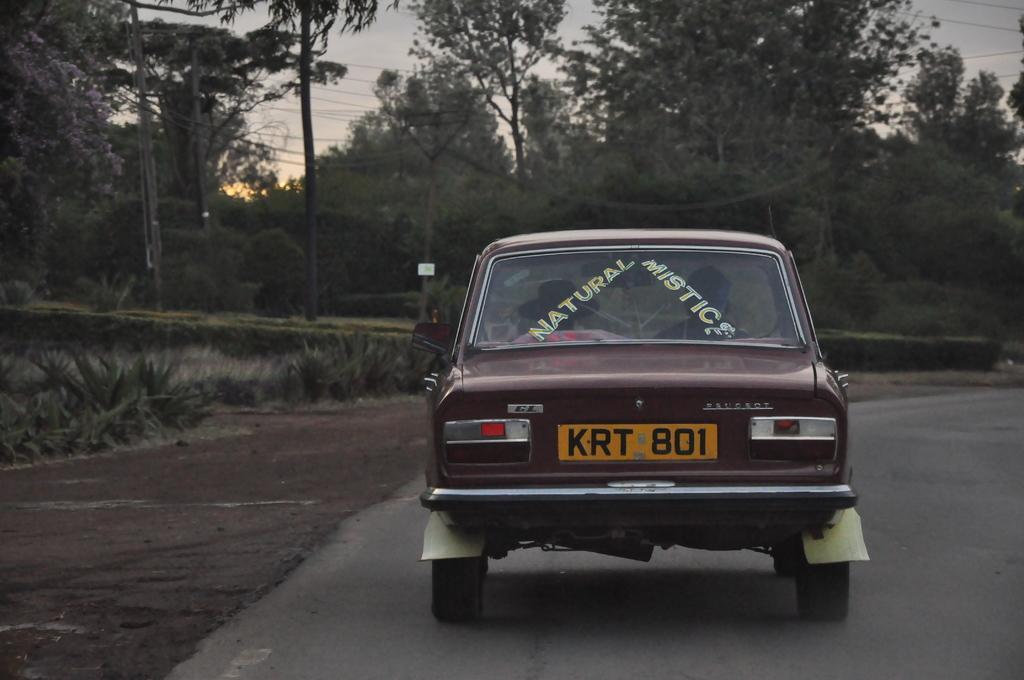Describe this image in one or two sentences. In the center of the image we can see car on the road. In the background we can see trees, plants, wires and sky. 